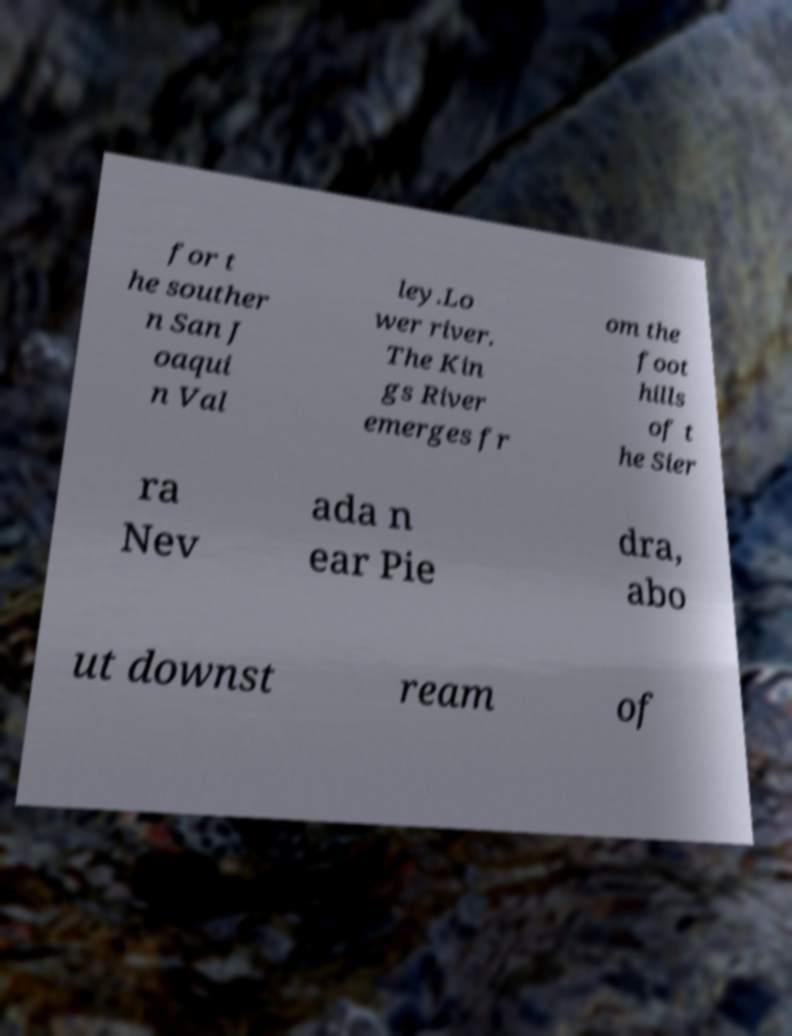There's text embedded in this image that I need extracted. Can you transcribe it verbatim? for t he souther n San J oaqui n Val ley.Lo wer river. The Kin gs River emerges fr om the foot hills of t he Sier ra Nev ada n ear Pie dra, abo ut downst ream of 